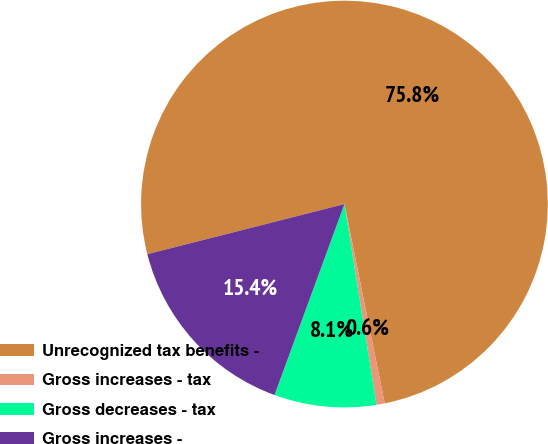Convert chart. <chart><loc_0><loc_0><loc_500><loc_500><pie_chart><fcel>Unrecognized tax benefits -<fcel>Gross increases - tax<fcel>Gross decreases - tax<fcel>Gross increases -<nl><fcel>75.79%<fcel>0.65%<fcel>8.11%<fcel>15.45%<nl></chart> 